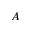<formula> <loc_0><loc_0><loc_500><loc_500>A</formula> 